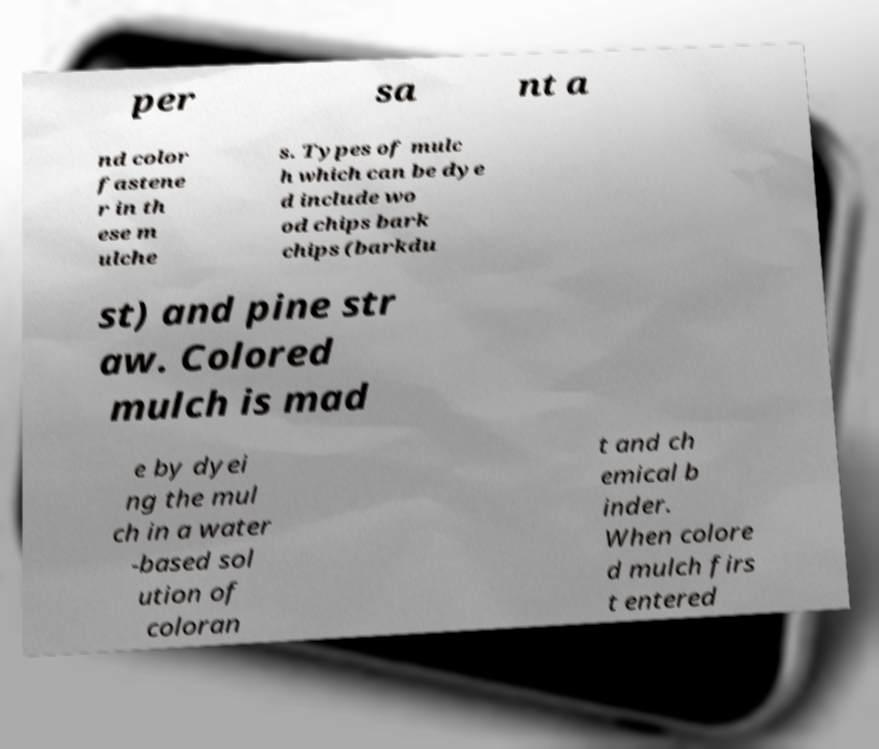I need the written content from this picture converted into text. Can you do that? per sa nt a nd color fastene r in th ese m ulche s. Types of mulc h which can be dye d include wo od chips bark chips (barkdu st) and pine str aw. Colored mulch is mad e by dyei ng the mul ch in a water -based sol ution of coloran t and ch emical b inder. When colore d mulch firs t entered 